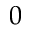<formula> <loc_0><loc_0><loc_500><loc_500>0</formula> 